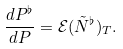Convert formula to latex. <formula><loc_0><loc_0><loc_500><loc_500>\frac { d P ^ { \flat } } { d P } = \mathcal { E } ( \tilde { N } ^ { \flat } ) _ { T } .</formula> 